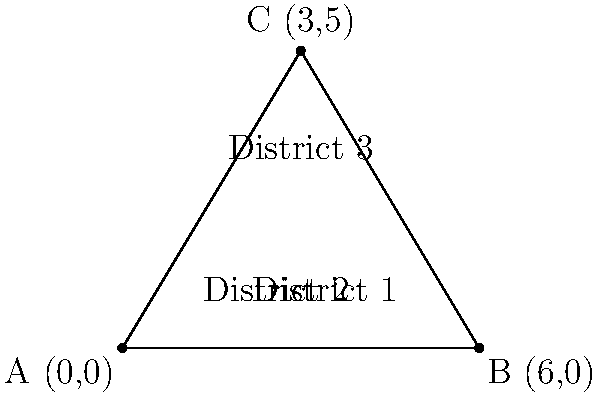As a local reporter covering Dutchess County politics, you've been tasked with analyzing the geographical distribution of three key voting districts. The districts form a triangular region on a coordinate system, with vertices at (0,0), (6,0), and (3,5). What is the total area, in square units, of this triangular region encompassing these three voting districts? To find the area of the triangular region, we can use the formula for the area of a triangle given the coordinates of its vertices:

Area = $\frac{1}{2}|x_1(y_2 - y_3) + x_2(y_3 - y_1) + x_3(y_1 - y_2)|$

Where $(x_1, y_1)$, $(x_2, y_2)$, and $(x_3, y_3)$ are the coordinates of the three vertices.

Given:
- Vertex A: (0, 0)
- Vertex B: (6, 0)
- Vertex C: (3, 5)

Step 1: Plug the coordinates into the formula:
Area = $\frac{1}{2}|0(0 - 5) + 6(5 - 0) + 3(0 - 0)|$

Step 2: Simplify:
Area = $\frac{1}{2}|0 + 30 + 0|$

Step 3: Calculate:
Area = $\frac{1}{2}(30)$ = 15

Therefore, the area of the triangular region formed by the three voting districts is 15 square units.
Answer: 15 square units 